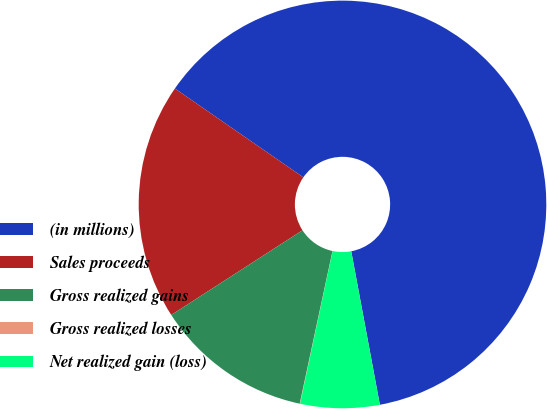<chart> <loc_0><loc_0><loc_500><loc_500><pie_chart><fcel>(in millions)<fcel>Sales proceeds<fcel>Gross realized gains<fcel>Gross realized losses<fcel>Net realized gain (loss)<nl><fcel>62.43%<fcel>18.75%<fcel>12.51%<fcel>0.03%<fcel>6.27%<nl></chart> 